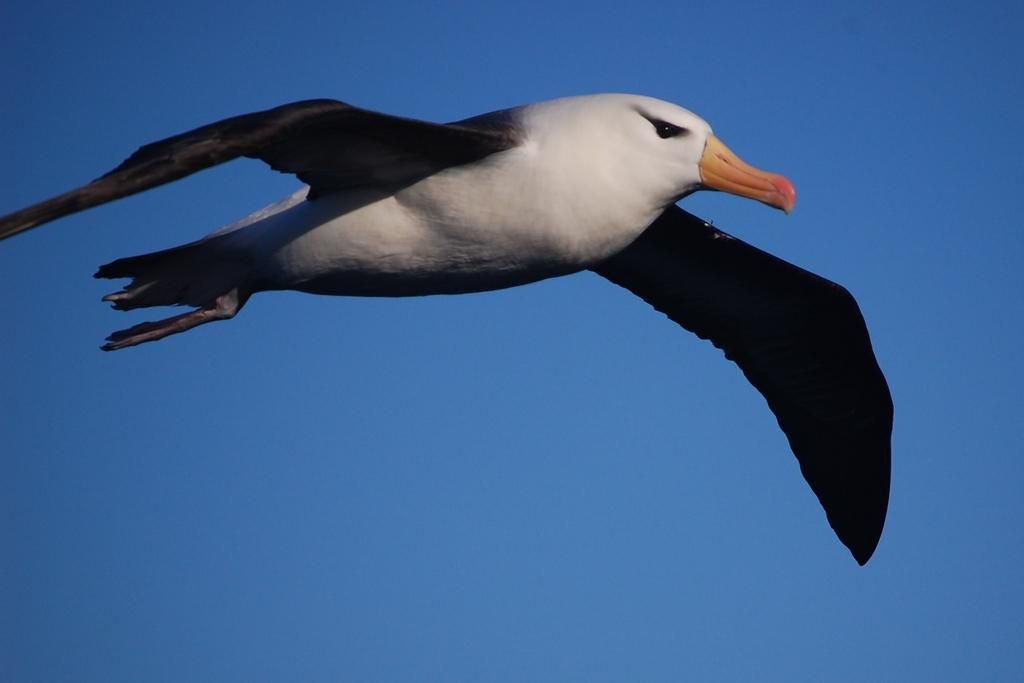What type of animal can be seen in the image? There is a bird in the image. What is the bird doing in the image? The bird is flying in the sky. What color is the rose held by the man in the image? There are no men or roses present in the image; it only features a bird flying in the sky. 